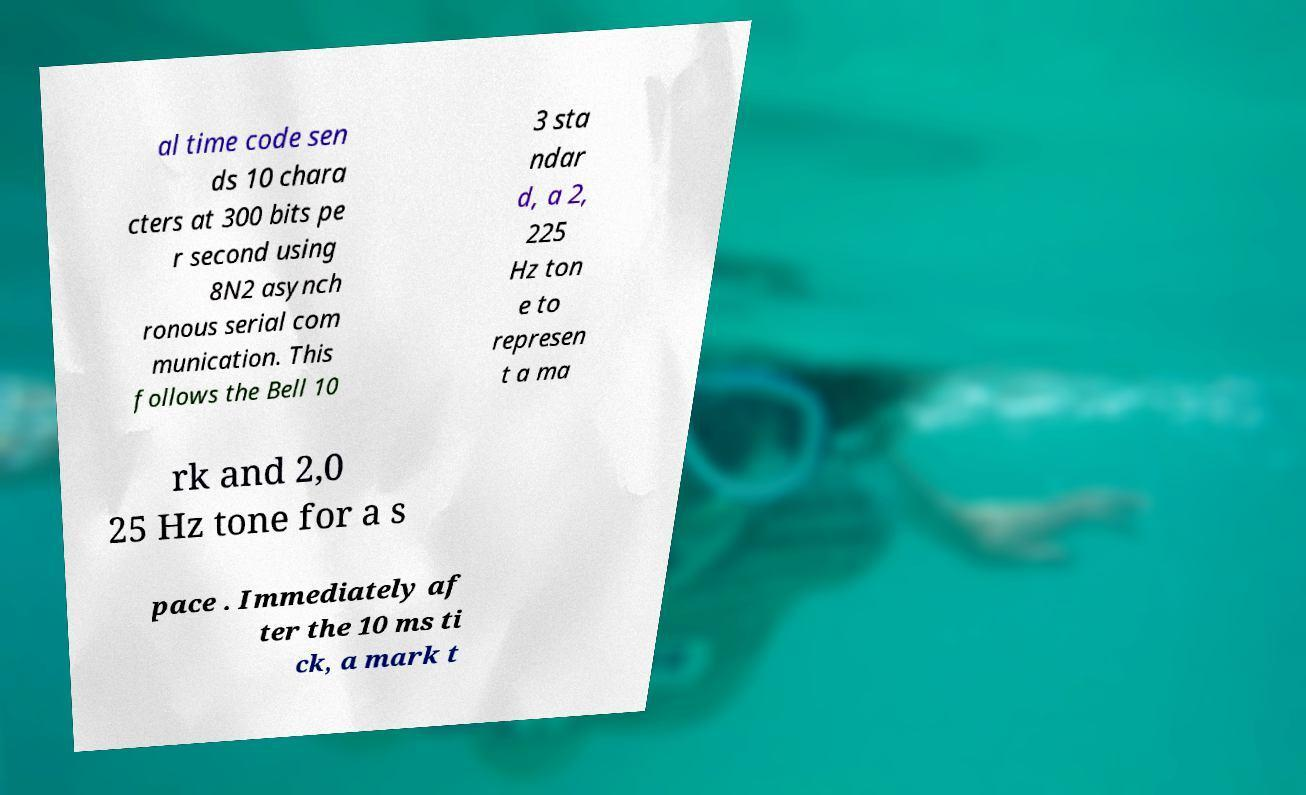Could you assist in decoding the text presented in this image and type it out clearly? al time code sen ds 10 chara cters at 300 bits pe r second using 8N2 asynch ronous serial com munication. This follows the Bell 10 3 sta ndar d, a 2, 225 Hz ton e to represen t a ma rk and 2,0 25 Hz tone for a s pace . Immediately af ter the 10 ms ti ck, a mark t 